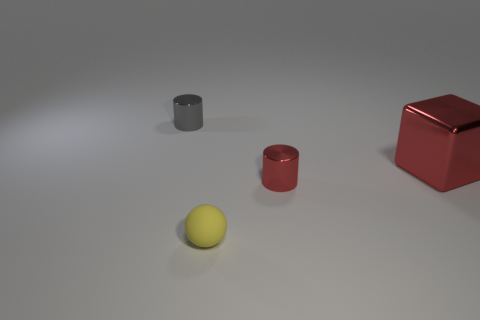Is there any other thing that is the same size as the shiny block?
Your response must be concise. No. There is a red object that is the same shape as the small gray metal thing; what is its size?
Give a very brief answer. Small. Are there more shiny things that are in front of the red cube than tiny metallic cylinders?
Offer a very short reply. No. Is the thing left of the small rubber ball made of the same material as the large object?
Provide a succinct answer. Yes. How big is the gray shiny cylinder that is left of the tiny matte object in front of the metal thing that is right of the red cylinder?
Provide a succinct answer. Small. What size is the gray cylinder that is the same material as the red cylinder?
Your response must be concise. Small. What color is the thing that is both on the left side of the large red cube and to the right of the tiny ball?
Keep it short and to the point. Red. There is a tiny shiny object that is to the left of the ball; is it the same shape as the small metallic thing on the right side of the gray thing?
Your answer should be very brief. Yes. What material is the tiny cylinder behind the large red metallic object?
Give a very brief answer. Metal. There is a cylinder that is the same color as the metal block; what size is it?
Your answer should be compact. Small. 